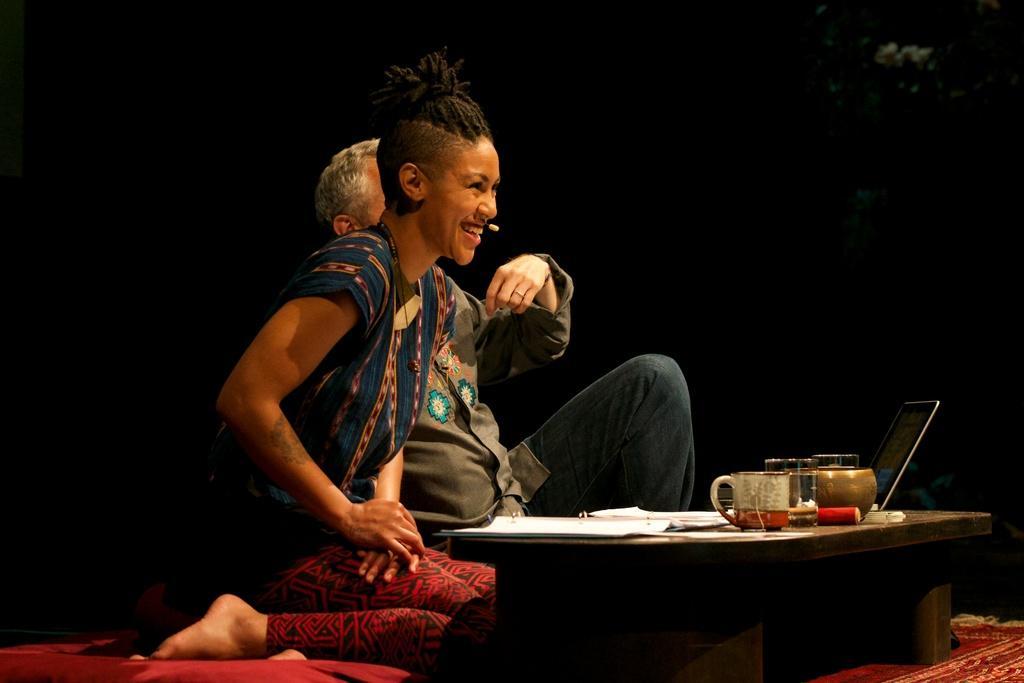In one or two sentences, can you explain what this image depicts? In this picture there are two people in the center of the image, in front of a stool, there are papers, cups, and a laptop on the stool. 